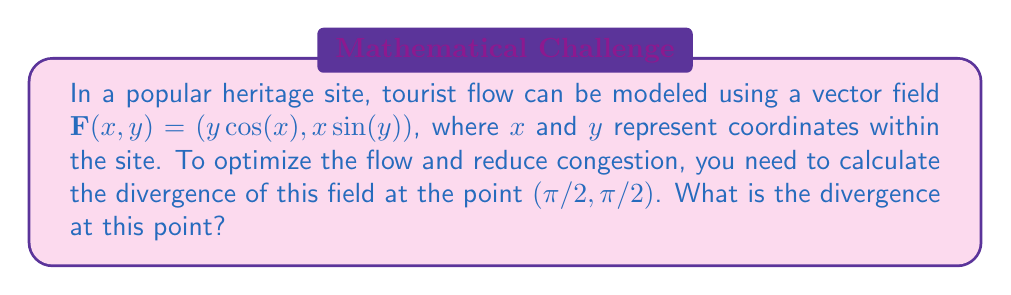Solve this math problem. To solve this problem, we'll follow these steps:

1) The divergence of a vector field $\mathbf{F}(x,y) = (P(x,y), Q(x,y))$ in 2D is given by:

   $$\text{div}\mathbf{F} = \nabla \cdot \mathbf{F} = \frac{\partial P}{\partial x} + \frac{\partial Q}{\partial y}$$

2) In our case, $P(x,y) = y\cos(x)$ and $Q(x,y) = x\sin(y)$

3) Let's calculate $\frac{\partial P}{\partial x}$:
   $$\frac{\partial P}{\partial x} = \frac{\partial}{\partial x}(y\cos(x)) = -y\sin(x)$$

4) Now, let's calculate $\frac{\partial Q}{\partial y}$:
   $$\frac{\partial Q}{\partial y} = \frac{\partial}{\partial y}(x\sin(y)) = x\cos(y)$$

5) The divergence is the sum of these partial derivatives:
   $$\text{div}\mathbf{F} = -y\sin(x) + x\cos(y)$$

6) We need to evaluate this at the point $(π/2, π/2)$:
   $$\text{div}\mathbf{F}(π/2, π/2) = -(π/2)\sin(π/2) + (π/2)\cos(π/2)$$

7) Simplify:
   $$\text{div}\mathbf{F}(π/2, π/2) = -(π/2)(1) + (π/2)(0) = -π/2$$

Therefore, the divergence at the point $(π/2, π/2)$ is $-π/2$.
Answer: $-π/2$ 